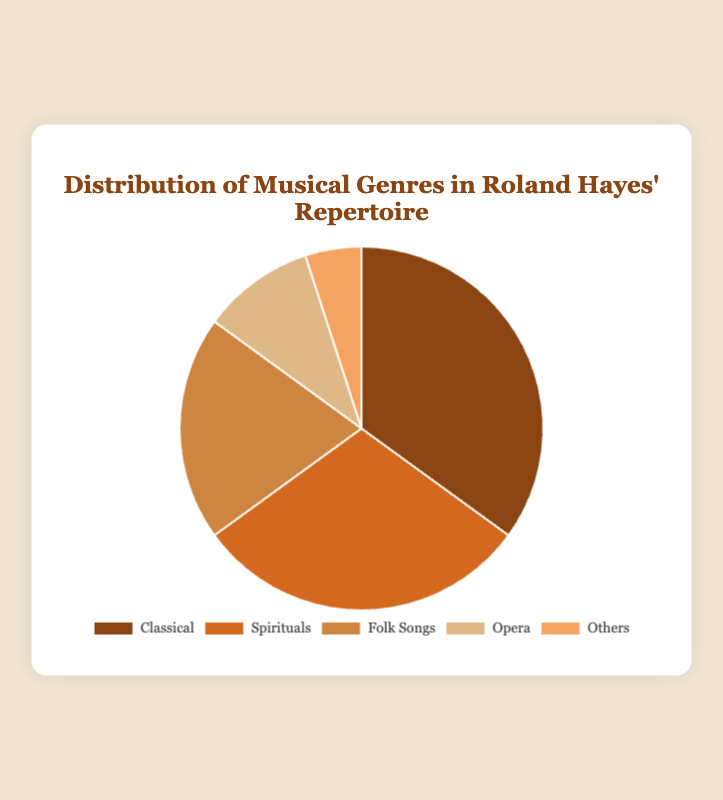what percentage of Roland Hayes' repertoire is composed of spirituals and folk songs combined? To find the combined percentage of spirituals and folk songs, simply add their individual percentages together: 30% (Spirituals) + 20% (Folk Songs) = 50%.
Answer: 50% Which genre makes up the largest portion of Roland Hayes' repertoire? By examining the percentages, we can see that the Classical genre accounts for 35%, which is the highest among all genres.
Answer: Classical How does the percentage of spirituals in Roland Hayes' repertoire compare to that of opera? To compare the two, we note that the spirituals make up 30% while opera makes up 10%. Thus, the percentage of spirituals is greater than that of opera.
Answer: Spirituals is greater than Opera If we wanted to represent the "Others" category with a different color, what percentage of Roland Hayes' repertoire would that new color represent? The "Others" category makes up 5% of Roland Hayes' repertoire.
Answer: 5% What is the difference in percentage between the genre with the largest repertoire and the genre with the smallest repertoire? The genre with the largest percentage is Classical at 35%, and the genre with the smallest percentage is Others at 5%. The difference is calculated as 35% - 5% = 30%.
Answer: 30% Which genre has a percentage that is exactly double the percentage of the "Others" category? The percentage of the "Others" category is 5%. Doubling this gives us 5% * 2 = 10%, which corresponds to the Opera genre.
Answer: Opera If you combined the Classical, Spirituals, and Folk Songs categories, what percentage of Roland Hayes' repertoire would these genres represent together? Add the percentages of Classical (35%), Spirituals (30%), and Folk Songs (20%) to get a combined total: 35% + 30% + 20% = 85%.
Answer: 85% Between Folk Songs and Opera, which genre covers a smaller portion of Roland Hayes' repertoire and by what percentage difference? Folk Songs account for 20% and Opera for 10%. The difference in their representation is 20% - 10% = 10%.
Answer: Opera, by 10% Looking at the colors used for each genre in the pie chart, which color represents the "Folk Songs" category? Based on the color scheme provided, the Folk Songs category is represented by the third color in the sequence, which is brown.
Answer: Brown 